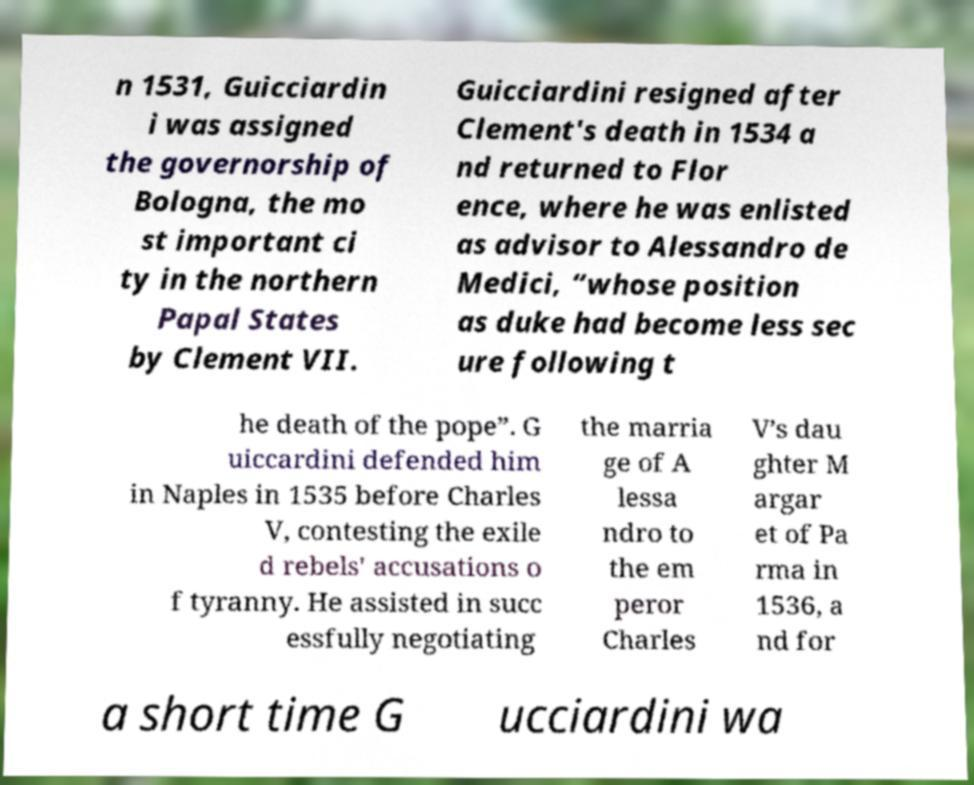Could you assist in decoding the text presented in this image and type it out clearly? n 1531, Guicciardin i was assigned the governorship of Bologna, the mo st important ci ty in the northern Papal States by Clement VII. Guicciardini resigned after Clement's death in 1534 a nd returned to Flor ence, where he was enlisted as advisor to Alessandro de Medici, “whose position as duke had become less sec ure following t he death of the pope”. G uiccardini defended him in Naples in 1535 before Charles V, contesting the exile d rebels' accusations o f tyranny. He assisted in succ essfully negotiating the marria ge of A lessa ndro to the em peror Charles V’s dau ghter M argar et of Pa rma in 1536, a nd for a short time G ucciardini wa 